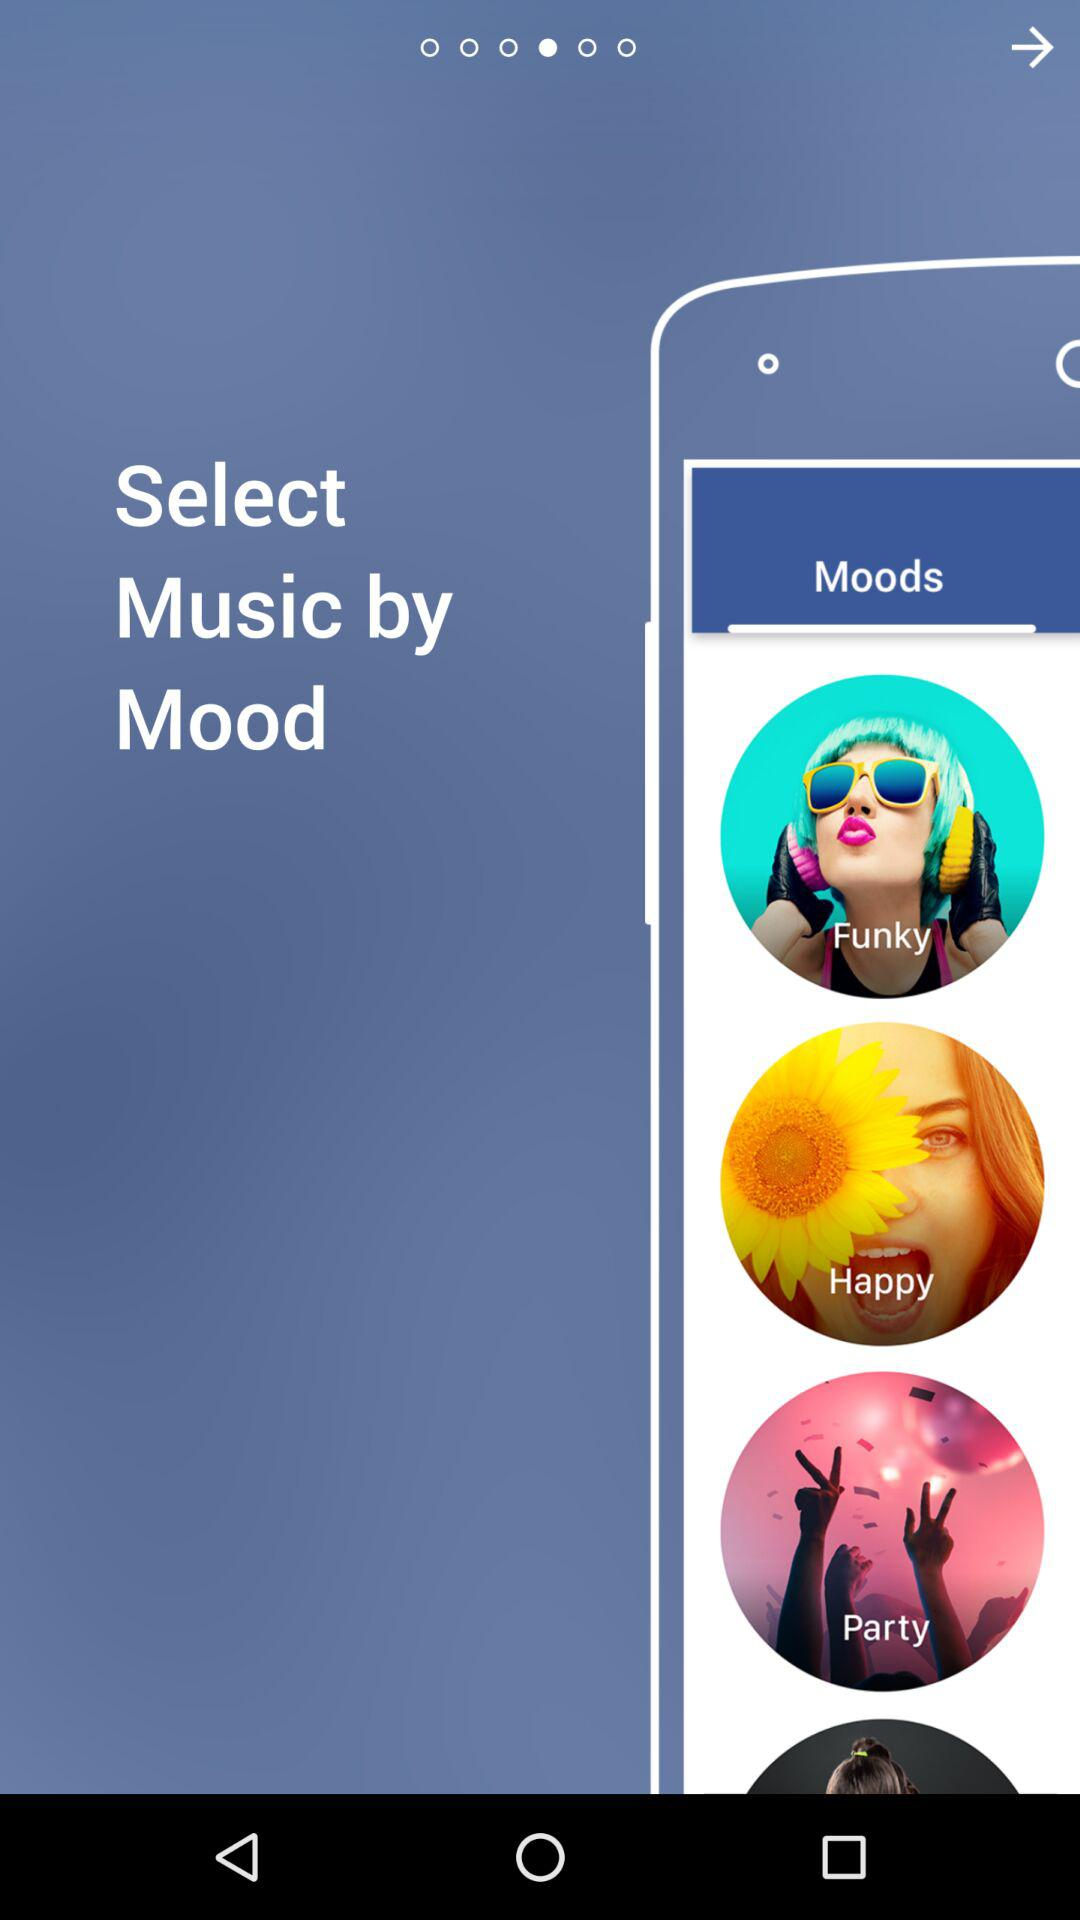What are the different types of moods? The different types of moods are "Funky", "Happy", and "Party". 